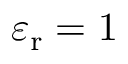Convert formula to latex. <formula><loc_0><loc_0><loc_500><loc_500>\varepsilon _ { r } = 1</formula> 